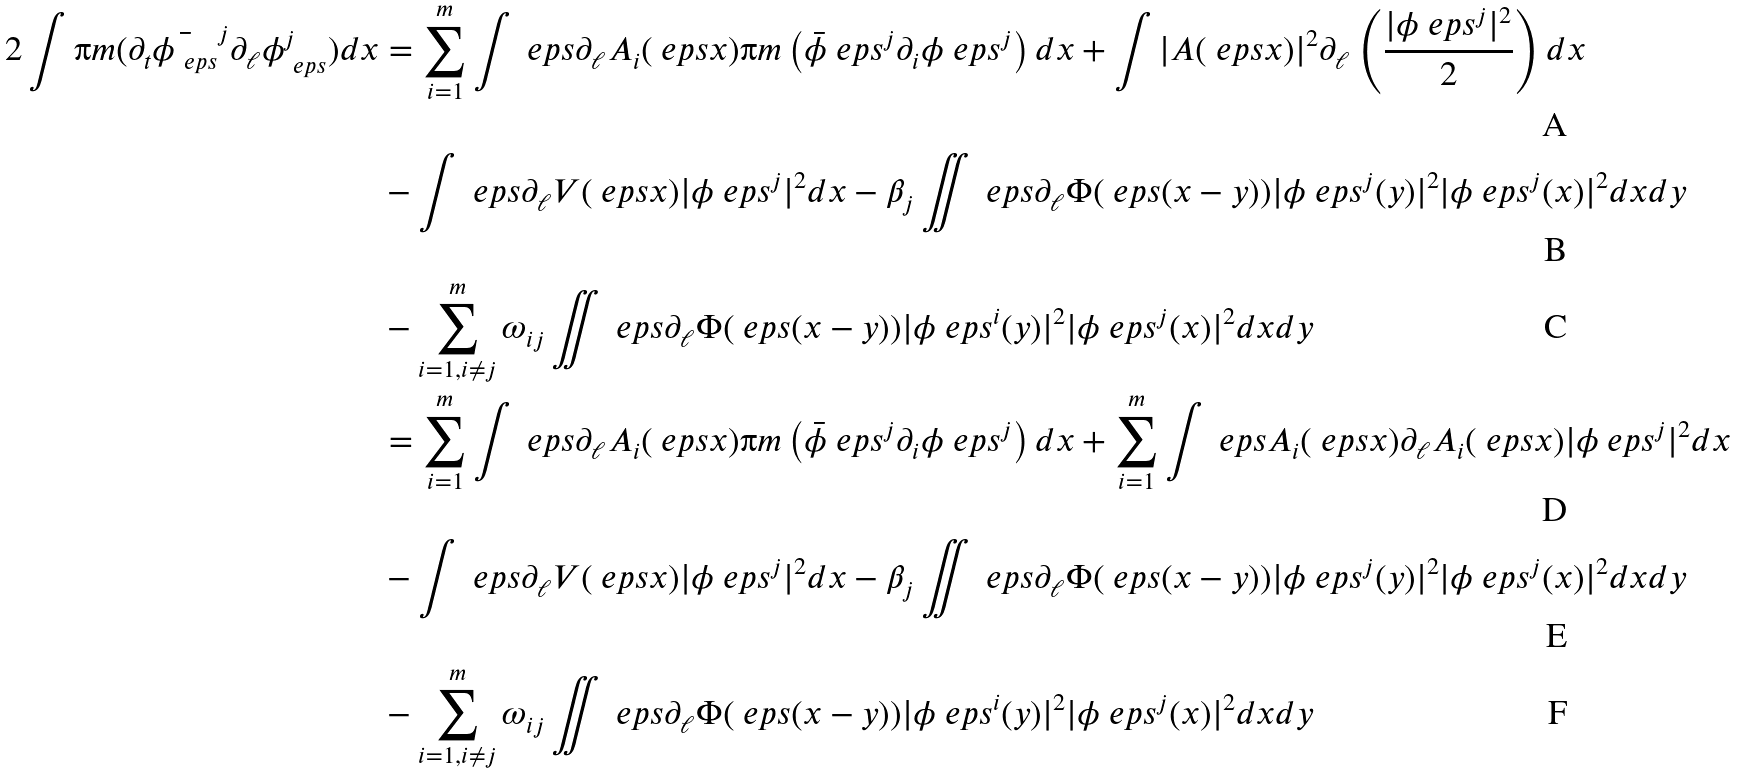Convert formula to latex. <formula><loc_0><loc_0><loc_500><loc_500>2 \int \i m ( \partial _ { t } \bar { \phi _ { \ e p s } } ^ { j } \partial _ { \ell } \phi _ { \ e p s } ^ { j } ) d x & = \sum _ { i = 1 } ^ { m } \int \ e p s \partial _ { \ell } A _ { i } ( \ e p s x ) \i m \left ( \bar { \phi } _ { \ } e p s ^ { j } \partial _ { i } \phi _ { \ } e p s ^ { j } \right ) d x + \int | A ( \ e p s x ) | ^ { 2 } \partial _ { \ell } \left ( \frac { | \phi _ { \ } e p s ^ { j } | ^ { 2 } } { 2 } \right ) d x \\ & - \int \ e p s \partial _ { \ell } V ( \ e p s x ) | \phi _ { \ } e p s ^ { j } | ^ { 2 } d x - \beta _ { j } \iint \ e p s \partial _ { \ell } \Phi ( \ e p s ( x - y ) ) | \phi _ { \ } e p s ^ { j } ( y ) | ^ { 2 } | \phi _ { \ } e p s ^ { j } ( x ) | ^ { 2 } d x d y \\ & - \sum _ { i = 1 , i \not = j } ^ { m } \omega _ { i j } \iint \ e p s \partial _ { \ell } \Phi ( \ e p s ( x - y ) ) | \phi _ { \ } e p s ^ { i } ( y ) | ^ { 2 } | \phi _ { \ } e p s ^ { j } ( x ) | ^ { 2 } d x d y \\ & = \sum _ { i = 1 } ^ { m } \int \ e p s \partial _ { \ell } A _ { i } ( \ e p s x ) \i m \left ( \bar { \phi } _ { \ } e p s ^ { j } \partial _ { i } \phi _ { \ } e p s ^ { j } \right ) d x + \sum _ { i = 1 } ^ { m } \int \ e p s A _ { i } ( \ e p s x ) \partial _ { \ell } A _ { i } ( \ e p s x ) | \phi _ { \ } e p s ^ { j } | ^ { 2 } d x \\ & - \int \ e p s \partial _ { \ell } V ( \ e p s x ) | \phi _ { \ } e p s ^ { j } | ^ { 2 } d x - \beta _ { j } \iint \ e p s \partial _ { \ell } \Phi ( \ e p s ( x - y ) ) | \phi _ { \ } e p s ^ { j } ( y ) | ^ { 2 } | \phi _ { \ } e p s ^ { j } ( x ) | ^ { 2 } d x d y \\ & - \sum _ { i = 1 , i \not = j } ^ { m } \omega _ { i j } \iint \ e p s \partial _ { \ell } \Phi ( \ e p s ( x - y ) ) | \phi _ { \ } e p s ^ { i } ( y ) | ^ { 2 } | \phi _ { \ } e p s ^ { j } ( x ) | ^ { 2 } d x d y</formula> 